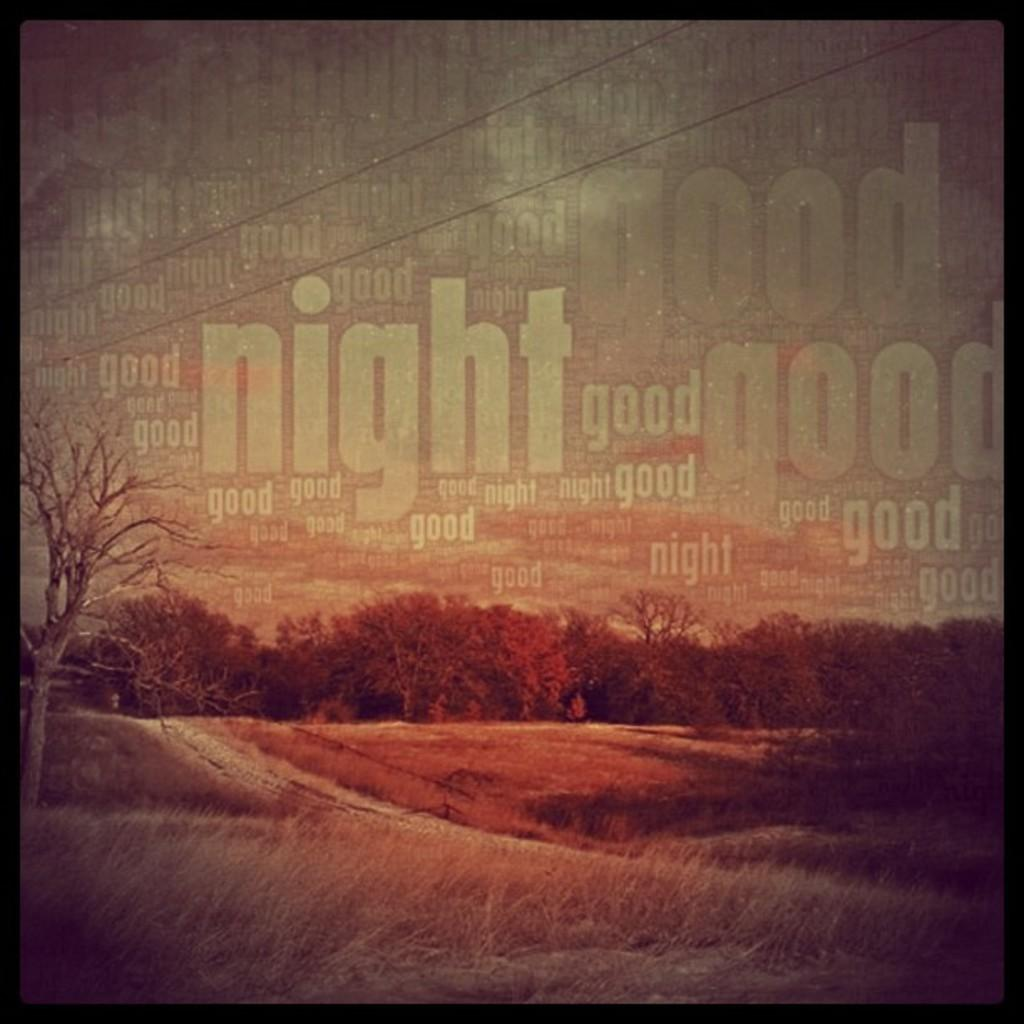How has the image been altered? The image is edited. What type of vegetation can be seen in the image? There are trees in the image. What is visible at the top of the image? The sky is visible at the top of the image. What can be found in the image that is related to electricity or communication? There are wires in the image. Are there any words or letters in the image? Yes, there is text in the image. What type of ground surface is present at the bottom of the image? There is grass at the bottom of the image. Where is the cart located in the image? There is no cart present in the image. What type of bread is being used in the meeting depicted in the image? There is no meeting or bread present in the image. 